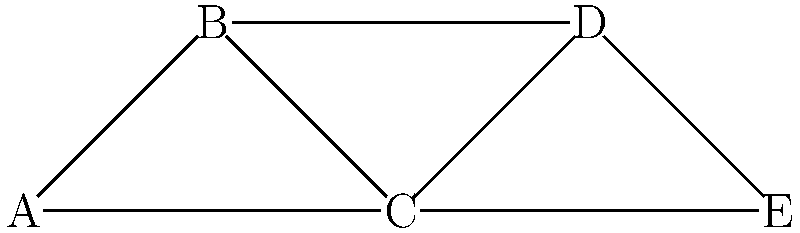In the network graph of startup founders shown above, which founder has the highest degree centrality, and what implications might this have for their role in the startup ecosystem? To answer this question, we need to follow these steps:

1. Understand degree centrality:
   Degree centrality is a measure of the number of direct connections a node has in a network.

2. Count connections for each founder:
   A: 2 connections
   B: 3 connections
   C: 4 connections
   D: 3 connections
   E: 2 connections

3. Identify the highest degree centrality:
   Founder C has the highest degree centrality with 4 connections.

4. Interpret the implications:
   a) Central position: Founder C is likely to be a key player in the startup ecosystem, acting as a hub for information and resources.
   b) Influence: They may have more influence over the flow of ideas and opportunities within the network.
   c) Access to diverse resources: With connections to different founders, C might have access to a wider range of skills, knowledge, and potential collaborations.
   d) Potential for brokerage: C could act as a bridge between different subgroups in the network, facilitating connections between otherwise unconnected founders.
   e) Leadership role: High centrality often correlates with leadership or coordinating roles within a community.
   f) Increased visibility: C may be more visible to investors, mentors, or other stakeholders in the ecosystem.

These implications suggest that Founder C may play a crucial role in shaping the dynamics and success of this particular startup ecosystem.
Answer: Founder C; central hub for information, resources, and connections 